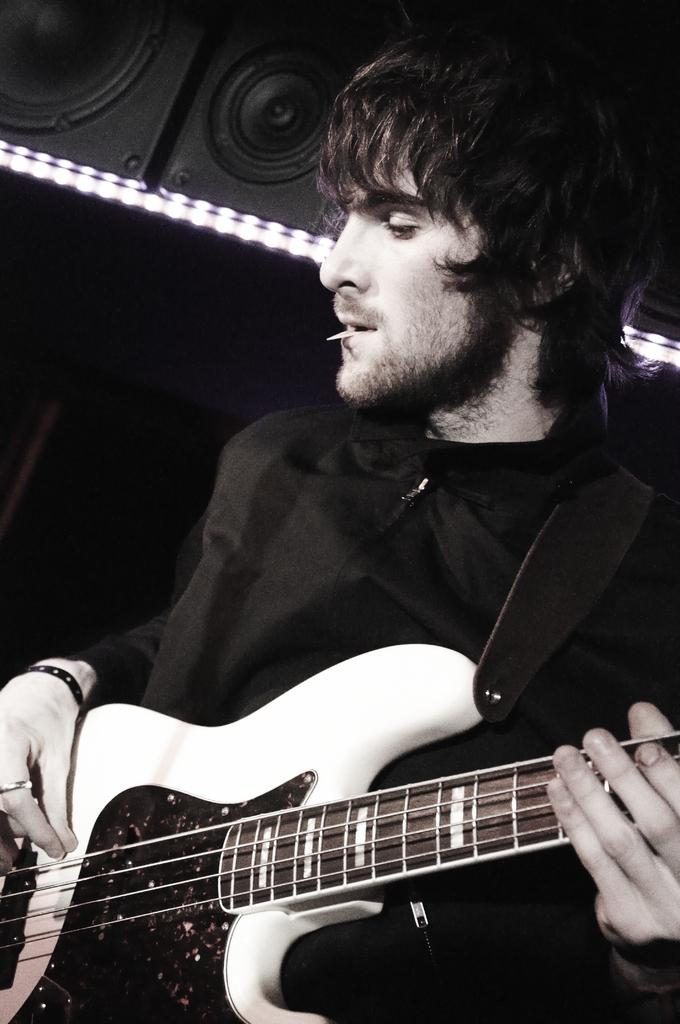What is the man in the image doing? The man is playing a guitar. What can be seen in the background of the image? There are black color speakers in the background of the image. How many rabbits are hopping around the man in the image? There are no rabbits present in the image. What substance is the man using to play the guitar in the image? The man is using his hands to play the guitar, and there is no mention of any substance being used. 